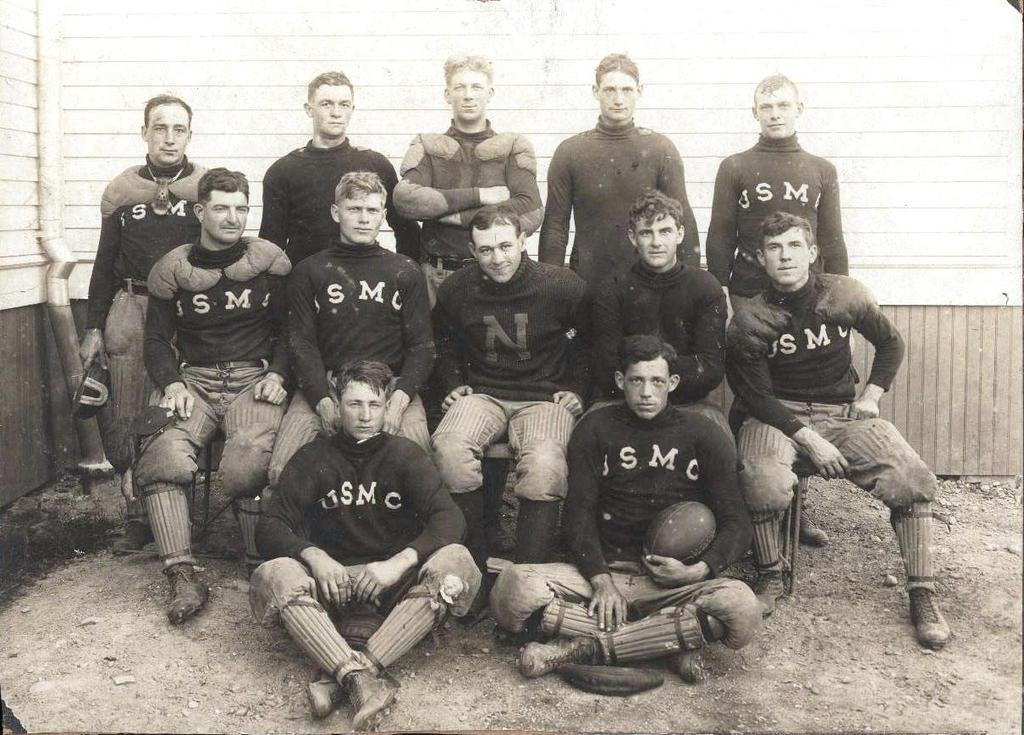What are the people in the image doing? There are people standing and sitting in the image. What can be seen on the ground in the image? The ground is visible in the image, and there are stones on the ground. What is present in the background of the image? There is a wall in the image, and there are objects attached to the wall. What type of egg is being used as a boat in the image? There is no egg or boat present in the image. What time of day is depicted in the image? The provided facts do not give any information about the time of day, so it cannot be determined from the image. 